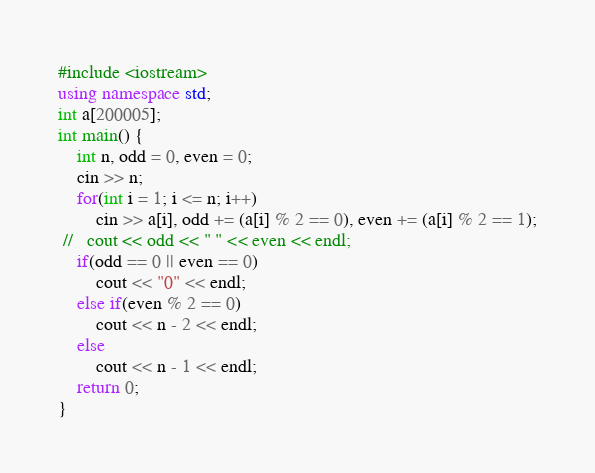Convert code to text. <code><loc_0><loc_0><loc_500><loc_500><_C++_>#include <iostream>
using namespace std;
int a[200005];
int main() {
    int n, odd = 0, even = 0;
    cin >> n;
    for(int i = 1; i <= n; i++)
        cin >> a[i], odd += (a[i] % 2 == 0), even += (a[i] % 2 == 1);
 //   cout << odd << " " << even << endl;
    if(odd == 0 || even == 0)
        cout << "0" << endl;
    else if(even % 2 == 0)
        cout << n - 2 << endl;
    else
        cout << n - 1 << endl;
    return 0;
}

</code> 